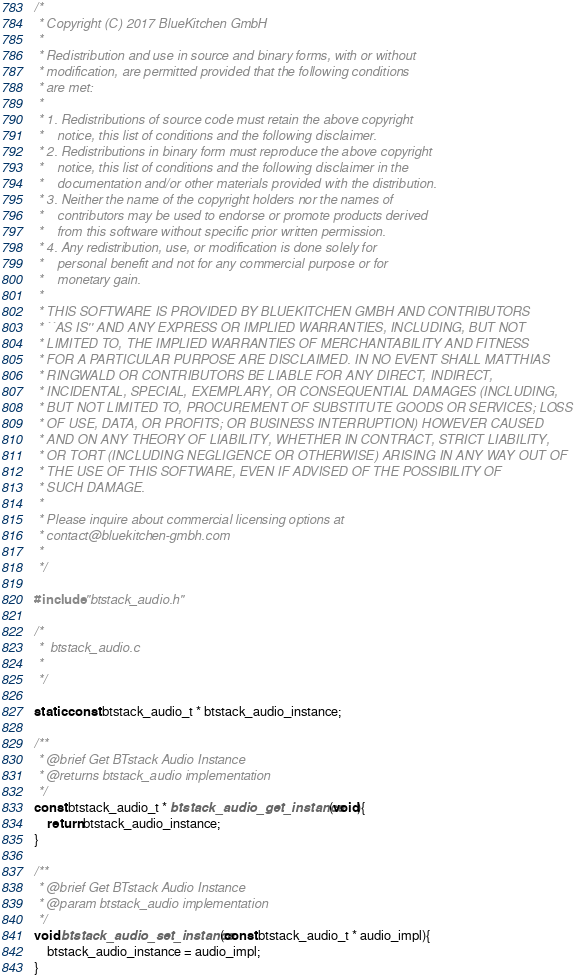Convert code to text. <code><loc_0><loc_0><loc_500><loc_500><_C_>/*
 * Copyright (C) 2017 BlueKitchen GmbH
 *
 * Redistribution and use in source and binary forms, with or without
 * modification, are permitted provided that the following conditions
 * are met:
 *
 * 1. Redistributions of source code must retain the above copyright
 *    notice, this list of conditions and the following disclaimer.
 * 2. Redistributions in binary form must reproduce the above copyright
 *    notice, this list of conditions and the following disclaimer in the
 *    documentation and/or other materials provided with the distribution.
 * 3. Neither the name of the copyright holders nor the names of
 *    contributors may be used to endorse or promote products derived
 *    from this software without specific prior written permission.
 * 4. Any redistribution, use, or modification is done solely for
 *    personal benefit and not for any commercial purpose or for
 *    monetary gain.
 *
 * THIS SOFTWARE IS PROVIDED BY BLUEKITCHEN GMBH AND CONTRIBUTORS
 * ``AS IS'' AND ANY EXPRESS OR IMPLIED WARRANTIES, INCLUDING, BUT NOT
 * LIMITED TO, THE IMPLIED WARRANTIES OF MERCHANTABILITY AND FITNESS
 * FOR A PARTICULAR PURPOSE ARE DISCLAIMED. IN NO EVENT SHALL MATTHIAS
 * RINGWALD OR CONTRIBUTORS BE LIABLE FOR ANY DIRECT, INDIRECT,
 * INCIDENTAL, SPECIAL, EXEMPLARY, OR CONSEQUENTIAL DAMAGES (INCLUDING,
 * BUT NOT LIMITED TO, PROCUREMENT OF SUBSTITUTE GOODS OR SERVICES; LOSS
 * OF USE, DATA, OR PROFITS; OR BUSINESS INTERRUPTION) HOWEVER CAUSED
 * AND ON ANY THEORY OF LIABILITY, WHETHER IN CONTRACT, STRICT LIABILITY,
 * OR TORT (INCLUDING NEGLIGENCE OR OTHERWISE) ARISING IN ANY WAY OUT OF
 * THE USE OF THIS SOFTWARE, EVEN IF ADVISED OF THE POSSIBILITY OF
 * SUCH DAMAGE.
 *
 * Please inquire about commercial licensing options at
 * contact@bluekitchen-gmbh.com
 *
 */

#include "btstack_audio.h"

/*
 *  btstack_audio.c
 *
 */

static const btstack_audio_t * btstack_audio_instance;

/**
 * @brief Get BTstack Audio Instance
 * @returns btstack_audio implementation
 */
const btstack_audio_t * btstack_audio_get_instance(void){
	return btstack_audio_instance;
}

/**
 * @brief Get BTstack Audio Instance
 * @param btstack_audio implementation
 */
void btstack_audio_set_instance(const btstack_audio_t * audio_impl){
	btstack_audio_instance = audio_impl;
}
</code> 